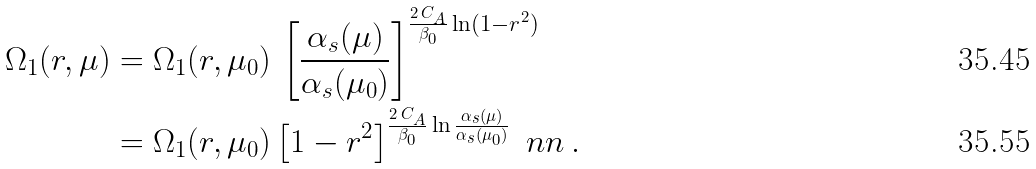<formula> <loc_0><loc_0><loc_500><loc_500>\Omega _ { 1 } ( r , \mu ) & = \Omega _ { 1 } ( r , \mu _ { 0 } ) \, \left [ \frac { \alpha _ { s } ( \mu ) } { \alpha _ { s } ( \mu _ { 0 } ) } \right ] ^ { \frac { 2 \, C _ { A } } { \beta _ { 0 } } \ln ( 1 - r ^ { 2 } ) } \\ & = \Omega _ { 1 } ( r , \mu _ { 0 } ) \left [ 1 - r ^ { 2 } \right ] ^ { \frac { 2 \, C _ { A } } { \beta _ { 0 } } \ln \frac { \alpha _ { s } ( \mu ) } { \alpha _ { s } ( \mu _ { 0 } ) } } \ n n \, .</formula> 